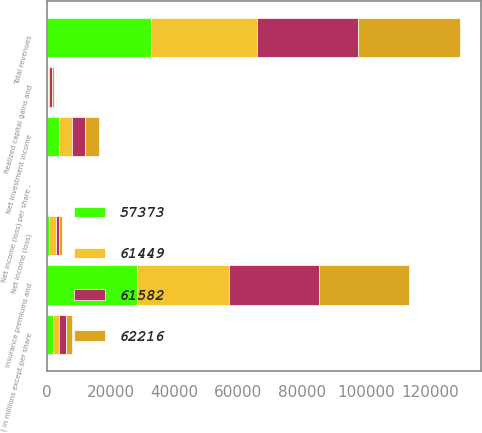<chart> <loc_0><loc_0><loc_500><loc_500><stacked_bar_chart><ecel><fcel>( in millions except per share<fcel>Insurance premiums and<fcel>Net investment income<fcel>Realized capital gains and<fcel>Total revenues<fcel>Net income (loss)<fcel>Net income (loss) per share -<nl><fcel>61449<fcel>2012<fcel>28978<fcel>4010<fcel>327<fcel>33315<fcel>2306<fcel>4.68<nl><fcel>57373<fcel>2011<fcel>28180<fcel>3971<fcel>503<fcel>32654<fcel>787<fcel>1.5<nl><fcel>61582<fcel>2010<fcel>28125<fcel>4102<fcel>827<fcel>31400<fcel>911<fcel>1.68<nl><fcel>62216<fcel>2009<fcel>28152<fcel>4444<fcel>583<fcel>32013<fcel>888<fcel>1.64<nl></chart> 